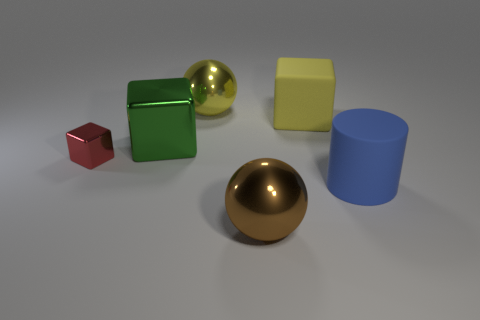Add 4 brown things. How many objects exist? 10 Subtract all balls. How many objects are left? 4 Subtract all gray shiny spheres. Subtract all big metallic blocks. How many objects are left? 5 Add 1 big yellow spheres. How many big yellow spheres are left? 2 Add 5 yellow spheres. How many yellow spheres exist? 6 Subtract 0 green balls. How many objects are left? 6 